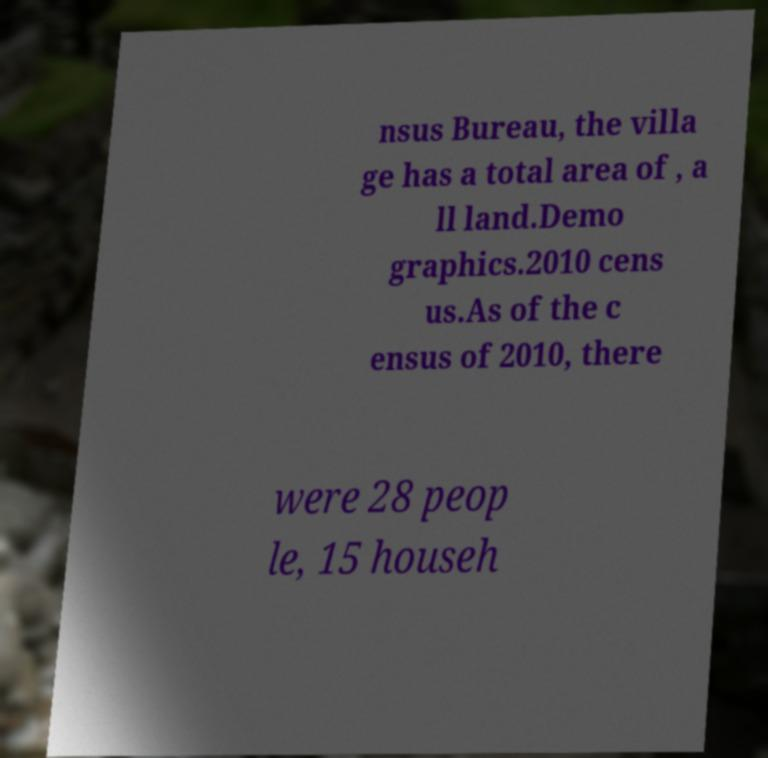Could you assist in decoding the text presented in this image and type it out clearly? nsus Bureau, the villa ge has a total area of , a ll land.Demo graphics.2010 cens us.As of the c ensus of 2010, there were 28 peop le, 15 househ 